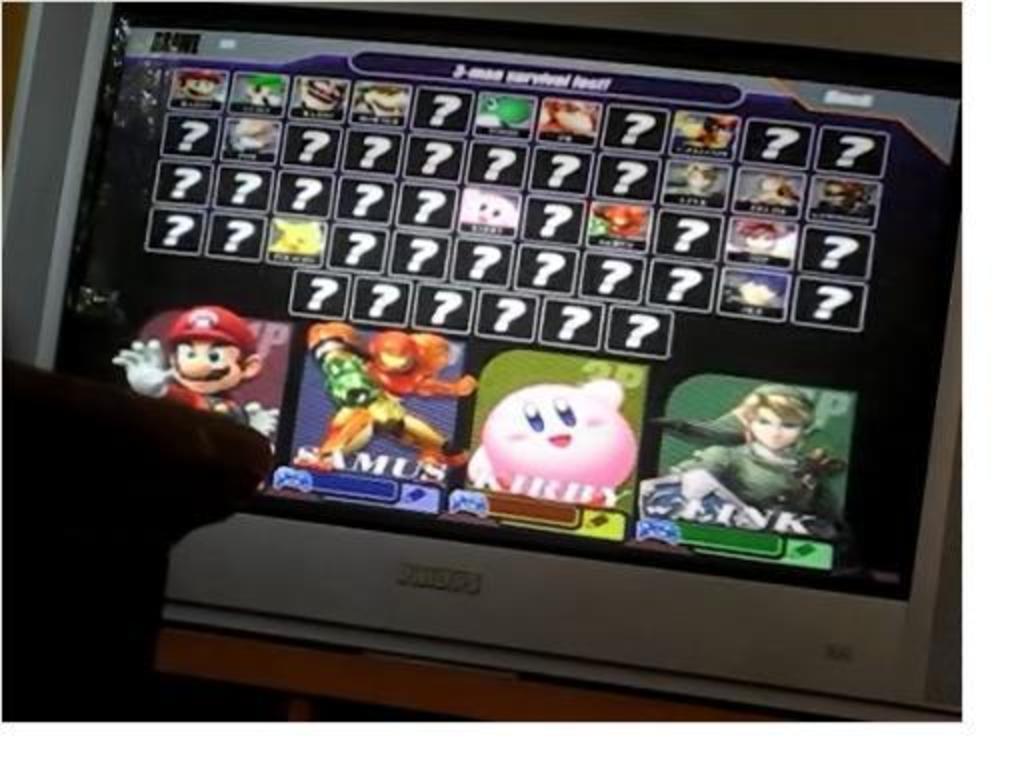In one or two sentences, can you explain what this image depicts? In this image, we can see a television on the wooden surface. On this screen, we can see symbols and animated figures. On the left side of the image, there is an object. 